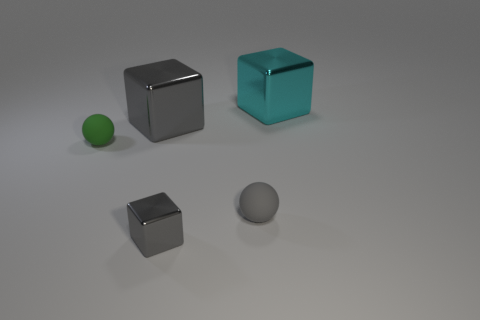There is a tiny shiny cube; is it the same color as the big thing that is to the left of the gray sphere?
Offer a very short reply. Yes. There is a small green thing; are there any big metallic things to the left of it?
Offer a terse response. No. What is the color of the other thing that is the same shape as the green thing?
Ensure brevity in your answer.  Gray. There is a small sphere that is on the left side of the tiny gray sphere; what is its material?
Give a very brief answer. Rubber. What size is the gray thing that is the same shape as the green rubber object?
Offer a very short reply. Small. What number of small green objects are made of the same material as the big cyan object?
Offer a very short reply. 0. How many metallic cubes have the same color as the tiny shiny object?
Offer a very short reply. 1. How many things are either metal cubes that are in front of the cyan object or gray cubes behind the tiny gray matte sphere?
Your answer should be compact. 2. Are there fewer large cubes in front of the big gray object than gray metallic things?
Offer a terse response. Yes. Is there a metal cube that has the same size as the gray sphere?
Offer a very short reply. Yes. 